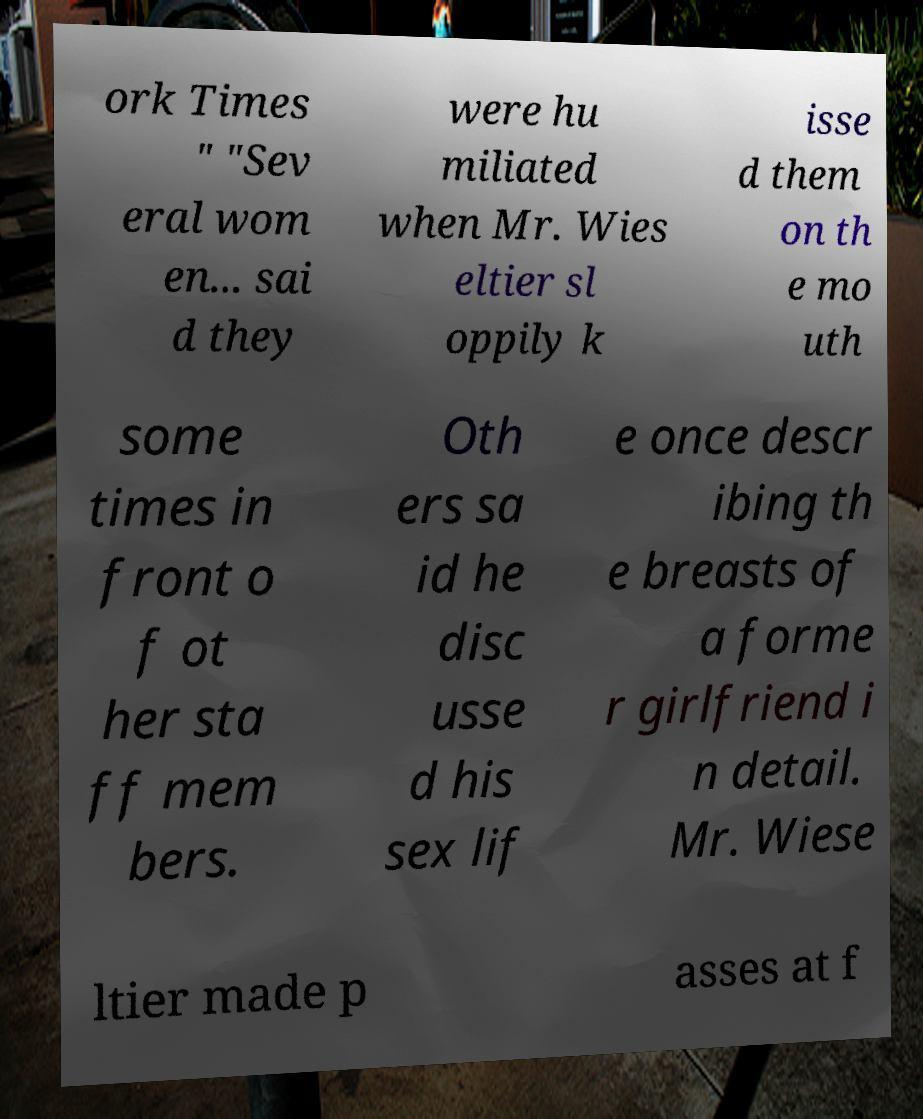Please read and relay the text visible in this image. What does it say? ork Times " "Sev eral wom en... sai d they were hu miliated when Mr. Wies eltier sl oppily k isse d them on th e mo uth some times in front o f ot her sta ff mem bers. Oth ers sa id he disc usse d his sex lif e once descr ibing th e breasts of a forme r girlfriend i n detail. Mr. Wiese ltier made p asses at f 